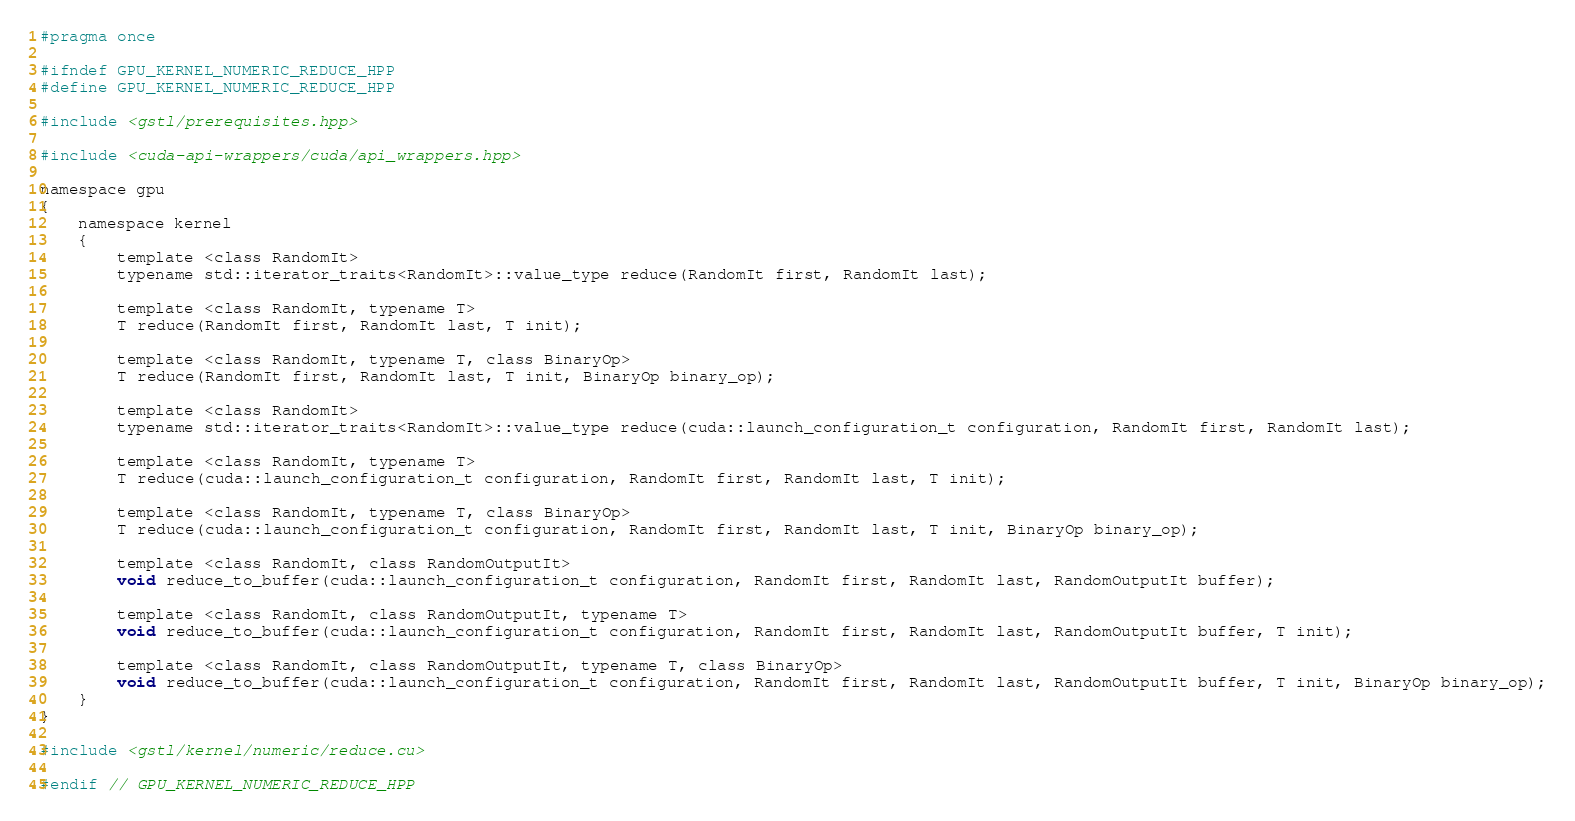<code> <loc_0><loc_0><loc_500><loc_500><_Cuda_>#pragma once

#ifndef GPU_KERNEL_NUMERIC_REDUCE_HPP
#define GPU_KERNEL_NUMERIC_REDUCE_HPP

#include <gstl/prerequisites.hpp>

#include <cuda-api-wrappers/cuda/api_wrappers.hpp>

namespace gpu
{
	namespace kernel
	{
		template <class RandomIt>
		typename std::iterator_traits<RandomIt>::value_type reduce(RandomIt first, RandomIt last);

		template <class RandomIt, typename T>
		T reduce(RandomIt first, RandomIt last, T init);

		template <class RandomIt, typename T, class BinaryOp>
		T reduce(RandomIt first, RandomIt last, T init, BinaryOp binary_op);

		template <class RandomIt>
		typename std::iterator_traits<RandomIt>::value_type reduce(cuda::launch_configuration_t configuration, RandomIt first, RandomIt last);

		template <class RandomIt, typename T>
		T reduce(cuda::launch_configuration_t configuration, RandomIt first, RandomIt last, T init);

		template <class RandomIt, typename T, class BinaryOp>
		T reduce(cuda::launch_configuration_t configuration, RandomIt first, RandomIt last, T init, BinaryOp binary_op);

		template <class RandomIt, class RandomOutputIt>
		void reduce_to_buffer(cuda::launch_configuration_t configuration, RandomIt first, RandomIt last, RandomOutputIt buffer);

		template <class RandomIt, class RandomOutputIt, typename T>
		void reduce_to_buffer(cuda::launch_configuration_t configuration, RandomIt first, RandomIt last, RandomOutputIt buffer, T init);

		template <class RandomIt, class RandomOutputIt, typename T, class BinaryOp>
		void reduce_to_buffer(cuda::launch_configuration_t configuration, RandomIt first, RandomIt last, RandomOutputIt buffer, T init, BinaryOp binary_op);
	}
}

#include <gstl/kernel/numeric/reduce.cu>

#endif // GPU_KERNEL_NUMERIC_REDUCE_HPP
</code> 